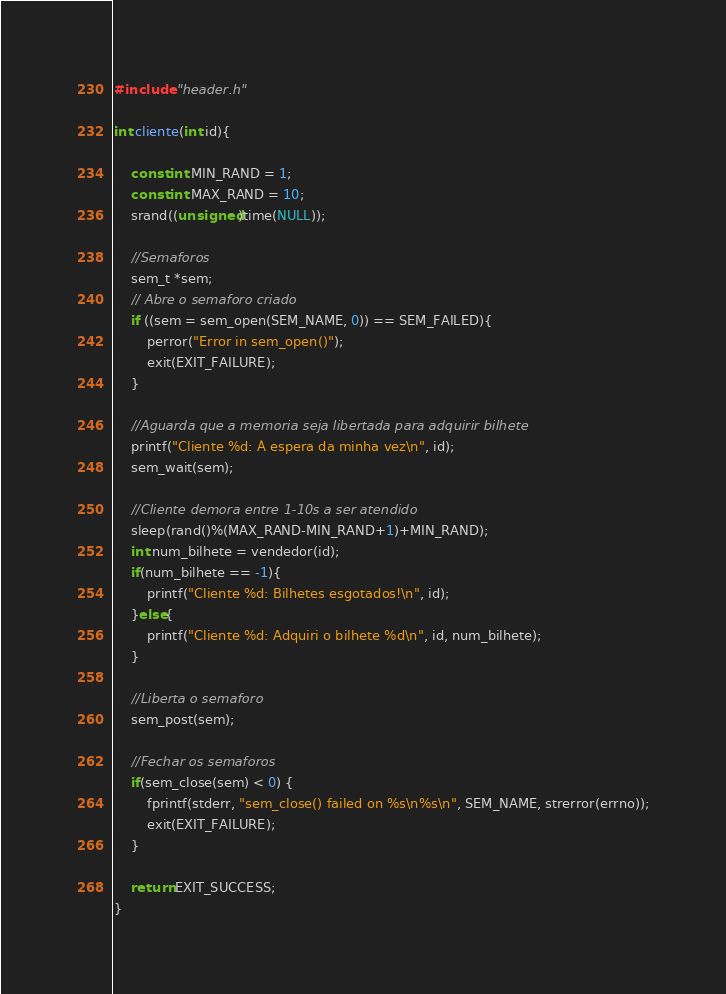Convert code to text. <code><loc_0><loc_0><loc_500><loc_500><_C_>#include "header.h"

int cliente(int id){
	
	const int MIN_RAND = 1;
	const int MAX_RAND = 10;
	srand((unsigned)time(NULL));
	
	//Semaforos
    sem_t *sem;
	// Abre o semaforo criado
    if ((sem = sem_open(SEM_NAME, 0)) == SEM_FAILED){
        perror("Error in sem_open()");
        exit(EXIT_FAILURE);
    }
    
	//Aguarda que a memoria seja libertada para adquirir bilhete
	printf("Cliente %d: À espera da minha vez\n", id);
	sem_wait(sem);
	
	//Cliente demora entre 1-10s a ser atendido
	sleep(rand()%(MAX_RAND-MIN_RAND+1)+MIN_RAND);
	int num_bilhete = vendedor(id);
	if(num_bilhete == -1){
		printf("Cliente %d: Bilhetes esgotados!\n", id);
	}else{
		printf("Cliente %d: Adquiri o bilhete %d\n", id, num_bilhete);
	}
	
	//Liberta o semaforo
	sem_post(sem);

	//Fechar os semaforos
	if(sem_close(sem) < 0) {
		fprintf(stderr, "sem_close() failed on %s\n%s\n", SEM_NAME, strerror(errno));
		exit(EXIT_FAILURE);
	}
	
	return EXIT_SUCCESS;
}
</code> 